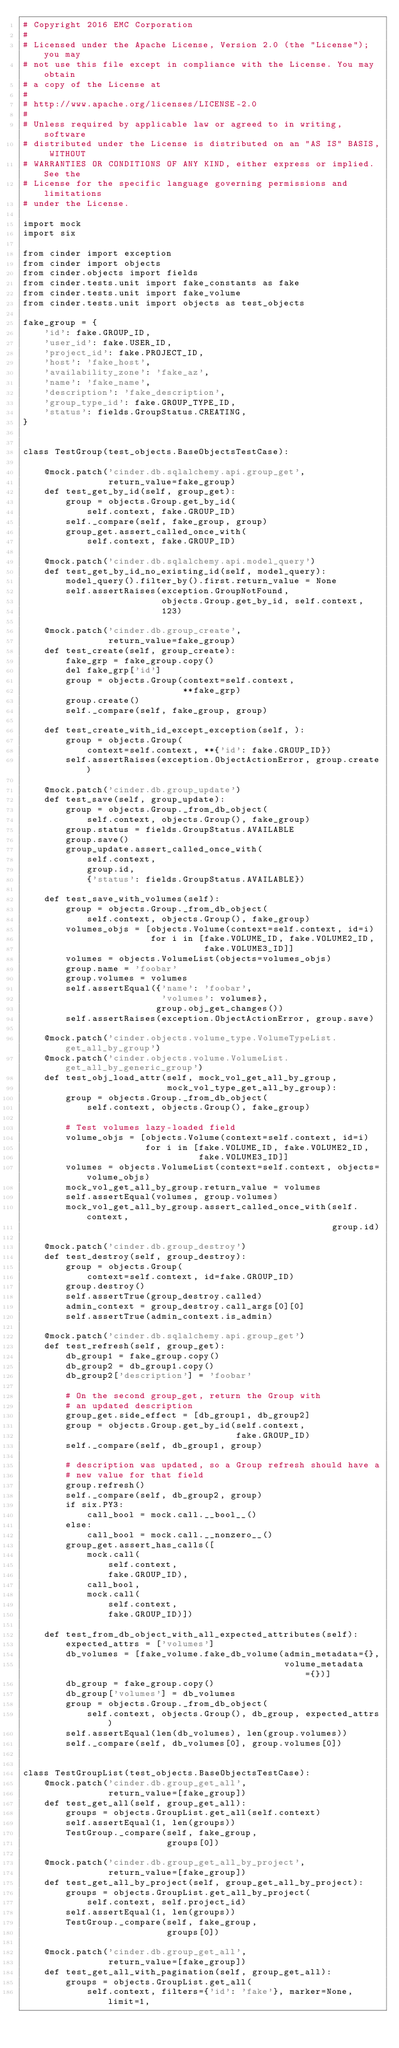<code> <loc_0><loc_0><loc_500><loc_500><_Python_># Copyright 2016 EMC Corporation
#
# Licensed under the Apache License, Version 2.0 (the "License"); you may
# not use this file except in compliance with the License. You may obtain
# a copy of the License at
#
# http://www.apache.org/licenses/LICENSE-2.0
#
# Unless required by applicable law or agreed to in writing, software
# distributed under the License is distributed on an "AS IS" BASIS, WITHOUT
# WARRANTIES OR CONDITIONS OF ANY KIND, either express or implied. See the
# License for the specific language governing permissions and limitations
# under the License.

import mock
import six

from cinder import exception
from cinder import objects
from cinder.objects import fields
from cinder.tests.unit import fake_constants as fake
from cinder.tests.unit import fake_volume
from cinder.tests.unit import objects as test_objects

fake_group = {
    'id': fake.GROUP_ID,
    'user_id': fake.USER_ID,
    'project_id': fake.PROJECT_ID,
    'host': 'fake_host',
    'availability_zone': 'fake_az',
    'name': 'fake_name',
    'description': 'fake_description',
    'group_type_id': fake.GROUP_TYPE_ID,
    'status': fields.GroupStatus.CREATING,
}


class TestGroup(test_objects.BaseObjectsTestCase):

    @mock.patch('cinder.db.sqlalchemy.api.group_get',
                return_value=fake_group)
    def test_get_by_id(self, group_get):
        group = objects.Group.get_by_id(
            self.context, fake.GROUP_ID)
        self._compare(self, fake_group, group)
        group_get.assert_called_once_with(
            self.context, fake.GROUP_ID)

    @mock.patch('cinder.db.sqlalchemy.api.model_query')
    def test_get_by_id_no_existing_id(self, model_query):
        model_query().filter_by().first.return_value = None
        self.assertRaises(exception.GroupNotFound,
                          objects.Group.get_by_id, self.context,
                          123)

    @mock.patch('cinder.db.group_create',
                return_value=fake_group)
    def test_create(self, group_create):
        fake_grp = fake_group.copy()
        del fake_grp['id']
        group = objects.Group(context=self.context,
                              **fake_grp)
        group.create()
        self._compare(self, fake_group, group)

    def test_create_with_id_except_exception(self, ):
        group = objects.Group(
            context=self.context, **{'id': fake.GROUP_ID})
        self.assertRaises(exception.ObjectActionError, group.create)

    @mock.patch('cinder.db.group_update')
    def test_save(self, group_update):
        group = objects.Group._from_db_object(
            self.context, objects.Group(), fake_group)
        group.status = fields.GroupStatus.AVAILABLE
        group.save()
        group_update.assert_called_once_with(
            self.context,
            group.id,
            {'status': fields.GroupStatus.AVAILABLE})

    def test_save_with_volumes(self):
        group = objects.Group._from_db_object(
            self.context, objects.Group(), fake_group)
        volumes_objs = [objects.Volume(context=self.context, id=i)
                        for i in [fake.VOLUME_ID, fake.VOLUME2_ID,
                                  fake.VOLUME3_ID]]
        volumes = objects.VolumeList(objects=volumes_objs)
        group.name = 'foobar'
        group.volumes = volumes
        self.assertEqual({'name': 'foobar',
                          'volumes': volumes},
                         group.obj_get_changes())
        self.assertRaises(exception.ObjectActionError, group.save)

    @mock.patch('cinder.objects.volume_type.VolumeTypeList.get_all_by_group')
    @mock.patch('cinder.objects.volume.VolumeList.get_all_by_generic_group')
    def test_obj_load_attr(self, mock_vol_get_all_by_group,
                           mock_vol_type_get_all_by_group):
        group = objects.Group._from_db_object(
            self.context, objects.Group(), fake_group)

        # Test volumes lazy-loaded field
        volume_objs = [objects.Volume(context=self.context, id=i)
                       for i in [fake.VOLUME_ID, fake.VOLUME2_ID,
                                 fake.VOLUME3_ID]]
        volumes = objects.VolumeList(context=self.context, objects=volume_objs)
        mock_vol_get_all_by_group.return_value = volumes
        self.assertEqual(volumes, group.volumes)
        mock_vol_get_all_by_group.assert_called_once_with(self.context,
                                                          group.id)

    @mock.patch('cinder.db.group_destroy')
    def test_destroy(self, group_destroy):
        group = objects.Group(
            context=self.context, id=fake.GROUP_ID)
        group.destroy()
        self.assertTrue(group_destroy.called)
        admin_context = group_destroy.call_args[0][0]
        self.assertTrue(admin_context.is_admin)

    @mock.patch('cinder.db.sqlalchemy.api.group_get')
    def test_refresh(self, group_get):
        db_group1 = fake_group.copy()
        db_group2 = db_group1.copy()
        db_group2['description'] = 'foobar'

        # On the second group_get, return the Group with
        # an updated description
        group_get.side_effect = [db_group1, db_group2]
        group = objects.Group.get_by_id(self.context,
                                        fake.GROUP_ID)
        self._compare(self, db_group1, group)

        # description was updated, so a Group refresh should have a
        # new value for that field
        group.refresh()
        self._compare(self, db_group2, group)
        if six.PY3:
            call_bool = mock.call.__bool__()
        else:
            call_bool = mock.call.__nonzero__()
        group_get.assert_has_calls([
            mock.call(
                self.context,
                fake.GROUP_ID),
            call_bool,
            mock.call(
                self.context,
                fake.GROUP_ID)])

    def test_from_db_object_with_all_expected_attributes(self):
        expected_attrs = ['volumes']
        db_volumes = [fake_volume.fake_db_volume(admin_metadata={},
                                                 volume_metadata={})]
        db_group = fake_group.copy()
        db_group['volumes'] = db_volumes
        group = objects.Group._from_db_object(
            self.context, objects.Group(), db_group, expected_attrs)
        self.assertEqual(len(db_volumes), len(group.volumes))
        self._compare(self, db_volumes[0], group.volumes[0])


class TestGroupList(test_objects.BaseObjectsTestCase):
    @mock.patch('cinder.db.group_get_all',
                return_value=[fake_group])
    def test_get_all(self, group_get_all):
        groups = objects.GroupList.get_all(self.context)
        self.assertEqual(1, len(groups))
        TestGroup._compare(self, fake_group,
                           groups[0])

    @mock.patch('cinder.db.group_get_all_by_project',
                return_value=[fake_group])
    def test_get_all_by_project(self, group_get_all_by_project):
        groups = objects.GroupList.get_all_by_project(
            self.context, self.project_id)
        self.assertEqual(1, len(groups))
        TestGroup._compare(self, fake_group,
                           groups[0])

    @mock.patch('cinder.db.group_get_all',
                return_value=[fake_group])
    def test_get_all_with_pagination(self, group_get_all):
        groups = objects.GroupList.get_all(
            self.context, filters={'id': 'fake'}, marker=None, limit=1,</code> 